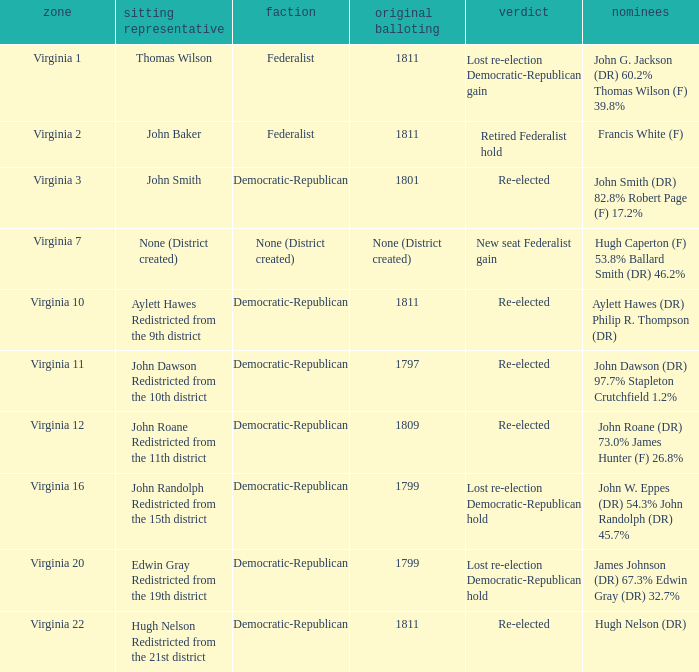Could you parse the entire table? {'header': ['zone', 'sitting representative', 'faction', 'original balloting', 'verdict', 'nominees'], 'rows': [['Virginia 1', 'Thomas Wilson', 'Federalist', '1811', 'Lost re-election Democratic-Republican gain', 'John G. Jackson (DR) 60.2% Thomas Wilson (F) 39.8%'], ['Virginia 2', 'John Baker', 'Federalist', '1811', 'Retired Federalist hold', 'Francis White (F)'], ['Virginia 3', 'John Smith', 'Democratic-Republican', '1801', 'Re-elected', 'John Smith (DR) 82.8% Robert Page (F) 17.2%'], ['Virginia 7', 'None (District created)', 'None (District created)', 'None (District created)', 'New seat Federalist gain', 'Hugh Caperton (F) 53.8% Ballard Smith (DR) 46.2%'], ['Virginia 10', 'Aylett Hawes Redistricted from the 9th district', 'Democratic-Republican', '1811', 'Re-elected', 'Aylett Hawes (DR) Philip R. Thompson (DR)'], ['Virginia 11', 'John Dawson Redistricted from the 10th district', 'Democratic-Republican', '1797', 'Re-elected', 'John Dawson (DR) 97.7% Stapleton Crutchfield 1.2%'], ['Virginia 12', 'John Roane Redistricted from the 11th district', 'Democratic-Republican', '1809', 'Re-elected', 'John Roane (DR) 73.0% James Hunter (F) 26.8%'], ['Virginia 16', 'John Randolph Redistricted from the 15th district', 'Democratic-Republican', '1799', 'Lost re-election Democratic-Republican hold', 'John W. Eppes (DR) 54.3% John Randolph (DR) 45.7%'], ['Virginia 20', 'Edwin Gray Redistricted from the 19th district', 'Democratic-Republican', '1799', 'Lost re-election Democratic-Republican hold', 'James Johnson (DR) 67.3% Edwin Gray (DR) 32.7%'], ['Virginia 22', 'Hugh Nelson Redistricted from the 21st district', 'Democratic-Republican', '1811', 'Re-elected', 'Hugh Nelson (DR)']]} Name the distrct for thomas wilson Virginia 1. 